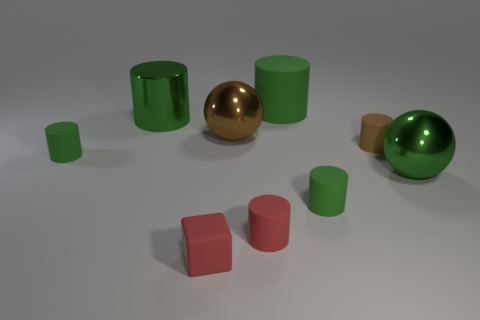Are there any large green metal spheres on the left side of the large green metallic thing that is behind the big green metal ball? Upon closer inspection of the image, there doesn’t appear to be any large green metal spheres on the left side behind the prominent green metal ball. What you can see is a series of cylindrical shapes and only one sphere, which is the central golden ball. 